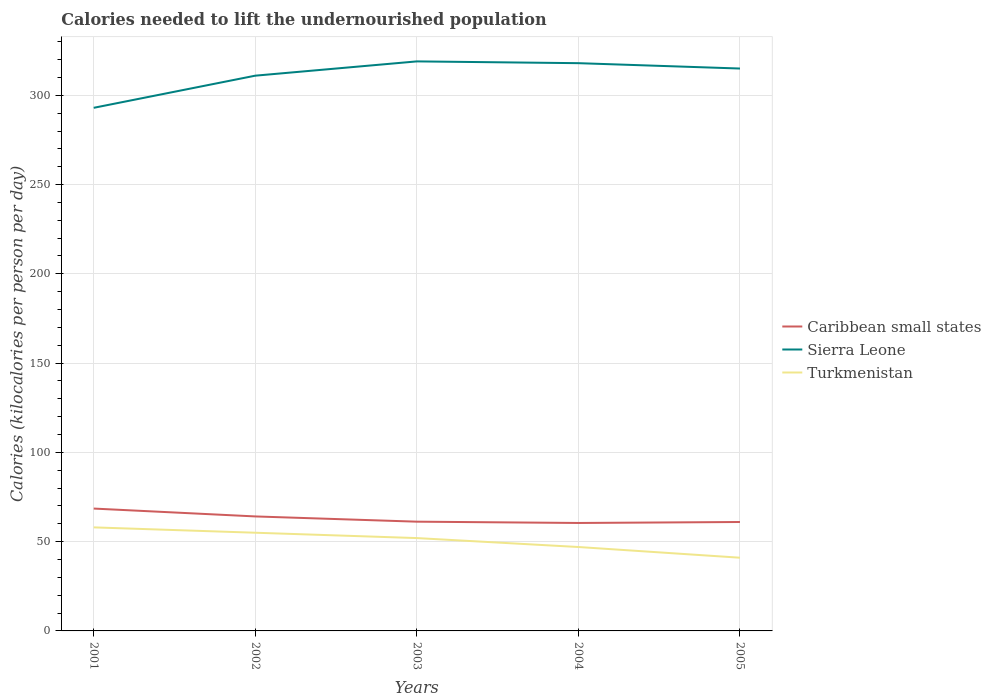Does the line corresponding to Caribbean small states intersect with the line corresponding to Sierra Leone?
Offer a terse response. No. Is the number of lines equal to the number of legend labels?
Give a very brief answer. Yes. Across all years, what is the maximum total calories needed to lift the undernourished population in Turkmenistan?
Ensure brevity in your answer.  41. In which year was the total calories needed to lift the undernourished population in Turkmenistan maximum?
Ensure brevity in your answer.  2005. What is the total total calories needed to lift the undernourished population in Turkmenistan in the graph?
Keep it short and to the point. 6. What is the difference between the highest and the second highest total calories needed to lift the undernourished population in Caribbean small states?
Your answer should be very brief. 8.07. What is the difference between the highest and the lowest total calories needed to lift the undernourished population in Turkmenistan?
Provide a succinct answer. 3. Is the total calories needed to lift the undernourished population in Caribbean small states strictly greater than the total calories needed to lift the undernourished population in Sierra Leone over the years?
Your response must be concise. Yes. How many lines are there?
Offer a terse response. 3. Does the graph contain any zero values?
Your answer should be very brief. No. Where does the legend appear in the graph?
Make the answer very short. Center right. How many legend labels are there?
Make the answer very short. 3. What is the title of the graph?
Provide a succinct answer. Calories needed to lift the undernourished population. Does "Channel Islands" appear as one of the legend labels in the graph?
Provide a succinct answer. No. What is the label or title of the Y-axis?
Make the answer very short. Calories (kilocalories per person per day). What is the Calories (kilocalories per person per day) in Caribbean small states in 2001?
Offer a terse response. 68.53. What is the Calories (kilocalories per person per day) in Sierra Leone in 2001?
Make the answer very short. 293. What is the Calories (kilocalories per person per day) in Turkmenistan in 2001?
Make the answer very short. 58. What is the Calories (kilocalories per person per day) in Caribbean small states in 2002?
Ensure brevity in your answer.  64.13. What is the Calories (kilocalories per person per day) of Sierra Leone in 2002?
Provide a short and direct response. 311. What is the Calories (kilocalories per person per day) in Caribbean small states in 2003?
Provide a succinct answer. 61.2. What is the Calories (kilocalories per person per day) of Sierra Leone in 2003?
Make the answer very short. 319. What is the Calories (kilocalories per person per day) of Caribbean small states in 2004?
Your answer should be very brief. 60.46. What is the Calories (kilocalories per person per day) of Sierra Leone in 2004?
Make the answer very short. 318. What is the Calories (kilocalories per person per day) in Caribbean small states in 2005?
Keep it short and to the point. 61.01. What is the Calories (kilocalories per person per day) of Sierra Leone in 2005?
Offer a terse response. 315. Across all years, what is the maximum Calories (kilocalories per person per day) of Caribbean small states?
Make the answer very short. 68.53. Across all years, what is the maximum Calories (kilocalories per person per day) in Sierra Leone?
Your answer should be compact. 319. Across all years, what is the maximum Calories (kilocalories per person per day) of Turkmenistan?
Provide a short and direct response. 58. Across all years, what is the minimum Calories (kilocalories per person per day) of Caribbean small states?
Keep it short and to the point. 60.46. Across all years, what is the minimum Calories (kilocalories per person per day) in Sierra Leone?
Provide a short and direct response. 293. Across all years, what is the minimum Calories (kilocalories per person per day) of Turkmenistan?
Your answer should be very brief. 41. What is the total Calories (kilocalories per person per day) of Caribbean small states in the graph?
Your answer should be very brief. 315.33. What is the total Calories (kilocalories per person per day) of Sierra Leone in the graph?
Provide a short and direct response. 1556. What is the total Calories (kilocalories per person per day) in Turkmenistan in the graph?
Your response must be concise. 253. What is the difference between the Calories (kilocalories per person per day) in Caribbean small states in 2001 and that in 2002?
Provide a succinct answer. 4.41. What is the difference between the Calories (kilocalories per person per day) in Sierra Leone in 2001 and that in 2002?
Offer a very short reply. -18. What is the difference between the Calories (kilocalories per person per day) of Turkmenistan in 2001 and that in 2002?
Give a very brief answer. 3. What is the difference between the Calories (kilocalories per person per day) in Caribbean small states in 2001 and that in 2003?
Keep it short and to the point. 7.34. What is the difference between the Calories (kilocalories per person per day) of Caribbean small states in 2001 and that in 2004?
Give a very brief answer. 8.07. What is the difference between the Calories (kilocalories per person per day) in Turkmenistan in 2001 and that in 2004?
Provide a succinct answer. 11. What is the difference between the Calories (kilocalories per person per day) in Caribbean small states in 2001 and that in 2005?
Make the answer very short. 7.53. What is the difference between the Calories (kilocalories per person per day) in Turkmenistan in 2001 and that in 2005?
Provide a short and direct response. 17. What is the difference between the Calories (kilocalories per person per day) of Caribbean small states in 2002 and that in 2003?
Your response must be concise. 2.93. What is the difference between the Calories (kilocalories per person per day) in Sierra Leone in 2002 and that in 2003?
Give a very brief answer. -8. What is the difference between the Calories (kilocalories per person per day) of Caribbean small states in 2002 and that in 2004?
Provide a short and direct response. 3.67. What is the difference between the Calories (kilocalories per person per day) of Sierra Leone in 2002 and that in 2004?
Your answer should be very brief. -7. What is the difference between the Calories (kilocalories per person per day) in Turkmenistan in 2002 and that in 2004?
Your answer should be compact. 8. What is the difference between the Calories (kilocalories per person per day) in Caribbean small states in 2002 and that in 2005?
Your response must be concise. 3.12. What is the difference between the Calories (kilocalories per person per day) of Turkmenistan in 2002 and that in 2005?
Ensure brevity in your answer.  14. What is the difference between the Calories (kilocalories per person per day) of Caribbean small states in 2003 and that in 2004?
Keep it short and to the point. 0.73. What is the difference between the Calories (kilocalories per person per day) in Caribbean small states in 2003 and that in 2005?
Make the answer very short. 0.19. What is the difference between the Calories (kilocalories per person per day) of Sierra Leone in 2003 and that in 2005?
Provide a short and direct response. 4. What is the difference between the Calories (kilocalories per person per day) of Caribbean small states in 2004 and that in 2005?
Offer a very short reply. -0.54. What is the difference between the Calories (kilocalories per person per day) of Turkmenistan in 2004 and that in 2005?
Provide a succinct answer. 6. What is the difference between the Calories (kilocalories per person per day) in Caribbean small states in 2001 and the Calories (kilocalories per person per day) in Sierra Leone in 2002?
Ensure brevity in your answer.  -242.47. What is the difference between the Calories (kilocalories per person per day) of Caribbean small states in 2001 and the Calories (kilocalories per person per day) of Turkmenistan in 2002?
Give a very brief answer. 13.53. What is the difference between the Calories (kilocalories per person per day) of Sierra Leone in 2001 and the Calories (kilocalories per person per day) of Turkmenistan in 2002?
Provide a succinct answer. 238. What is the difference between the Calories (kilocalories per person per day) of Caribbean small states in 2001 and the Calories (kilocalories per person per day) of Sierra Leone in 2003?
Ensure brevity in your answer.  -250.47. What is the difference between the Calories (kilocalories per person per day) in Caribbean small states in 2001 and the Calories (kilocalories per person per day) in Turkmenistan in 2003?
Offer a terse response. 16.53. What is the difference between the Calories (kilocalories per person per day) of Sierra Leone in 2001 and the Calories (kilocalories per person per day) of Turkmenistan in 2003?
Provide a succinct answer. 241. What is the difference between the Calories (kilocalories per person per day) of Caribbean small states in 2001 and the Calories (kilocalories per person per day) of Sierra Leone in 2004?
Offer a terse response. -249.47. What is the difference between the Calories (kilocalories per person per day) in Caribbean small states in 2001 and the Calories (kilocalories per person per day) in Turkmenistan in 2004?
Provide a succinct answer. 21.53. What is the difference between the Calories (kilocalories per person per day) in Sierra Leone in 2001 and the Calories (kilocalories per person per day) in Turkmenistan in 2004?
Give a very brief answer. 246. What is the difference between the Calories (kilocalories per person per day) of Caribbean small states in 2001 and the Calories (kilocalories per person per day) of Sierra Leone in 2005?
Provide a short and direct response. -246.47. What is the difference between the Calories (kilocalories per person per day) of Caribbean small states in 2001 and the Calories (kilocalories per person per day) of Turkmenistan in 2005?
Offer a very short reply. 27.53. What is the difference between the Calories (kilocalories per person per day) of Sierra Leone in 2001 and the Calories (kilocalories per person per day) of Turkmenistan in 2005?
Offer a terse response. 252. What is the difference between the Calories (kilocalories per person per day) of Caribbean small states in 2002 and the Calories (kilocalories per person per day) of Sierra Leone in 2003?
Provide a succinct answer. -254.87. What is the difference between the Calories (kilocalories per person per day) in Caribbean small states in 2002 and the Calories (kilocalories per person per day) in Turkmenistan in 2003?
Provide a short and direct response. 12.13. What is the difference between the Calories (kilocalories per person per day) of Sierra Leone in 2002 and the Calories (kilocalories per person per day) of Turkmenistan in 2003?
Keep it short and to the point. 259. What is the difference between the Calories (kilocalories per person per day) of Caribbean small states in 2002 and the Calories (kilocalories per person per day) of Sierra Leone in 2004?
Keep it short and to the point. -253.87. What is the difference between the Calories (kilocalories per person per day) of Caribbean small states in 2002 and the Calories (kilocalories per person per day) of Turkmenistan in 2004?
Offer a very short reply. 17.13. What is the difference between the Calories (kilocalories per person per day) of Sierra Leone in 2002 and the Calories (kilocalories per person per day) of Turkmenistan in 2004?
Give a very brief answer. 264. What is the difference between the Calories (kilocalories per person per day) of Caribbean small states in 2002 and the Calories (kilocalories per person per day) of Sierra Leone in 2005?
Keep it short and to the point. -250.87. What is the difference between the Calories (kilocalories per person per day) of Caribbean small states in 2002 and the Calories (kilocalories per person per day) of Turkmenistan in 2005?
Your response must be concise. 23.13. What is the difference between the Calories (kilocalories per person per day) in Sierra Leone in 2002 and the Calories (kilocalories per person per day) in Turkmenistan in 2005?
Offer a very short reply. 270. What is the difference between the Calories (kilocalories per person per day) in Caribbean small states in 2003 and the Calories (kilocalories per person per day) in Sierra Leone in 2004?
Your response must be concise. -256.8. What is the difference between the Calories (kilocalories per person per day) in Caribbean small states in 2003 and the Calories (kilocalories per person per day) in Turkmenistan in 2004?
Provide a succinct answer. 14.2. What is the difference between the Calories (kilocalories per person per day) of Sierra Leone in 2003 and the Calories (kilocalories per person per day) of Turkmenistan in 2004?
Offer a very short reply. 272. What is the difference between the Calories (kilocalories per person per day) of Caribbean small states in 2003 and the Calories (kilocalories per person per day) of Sierra Leone in 2005?
Your response must be concise. -253.8. What is the difference between the Calories (kilocalories per person per day) of Caribbean small states in 2003 and the Calories (kilocalories per person per day) of Turkmenistan in 2005?
Keep it short and to the point. 20.2. What is the difference between the Calories (kilocalories per person per day) of Sierra Leone in 2003 and the Calories (kilocalories per person per day) of Turkmenistan in 2005?
Your answer should be very brief. 278. What is the difference between the Calories (kilocalories per person per day) in Caribbean small states in 2004 and the Calories (kilocalories per person per day) in Sierra Leone in 2005?
Give a very brief answer. -254.54. What is the difference between the Calories (kilocalories per person per day) of Caribbean small states in 2004 and the Calories (kilocalories per person per day) of Turkmenistan in 2005?
Give a very brief answer. 19.46. What is the difference between the Calories (kilocalories per person per day) in Sierra Leone in 2004 and the Calories (kilocalories per person per day) in Turkmenistan in 2005?
Your answer should be very brief. 277. What is the average Calories (kilocalories per person per day) of Caribbean small states per year?
Ensure brevity in your answer.  63.07. What is the average Calories (kilocalories per person per day) in Sierra Leone per year?
Offer a very short reply. 311.2. What is the average Calories (kilocalories per person per day) in Turkmenistan per year?
Your answer should be very brief. 50.6. In the year 2001, what is the difference between the Calories (kilocalories per person per day) in Caribbean small states and Calories (kilocalories per person per day) in Sierra Leone?
Offer a terse response. -224.47. In the year 2001, what is the difference between the Calories (kilocalories per person per day) of Caribbean small states and Calories (kilocalories per person per day) of Turkmenistan?
Keep it short and to the point. 10.53. In the year 2001, what is the difference between the Calories (kilocalories per person per day) of Sierra Leone and Calories (kilocalories per person per day) of Turkmenistan?
Your response must be concise. 235. In the year 2002, what is the difference between the Calories (kilocalories per person per day) in Caribbean small states and Calories (kilocalories per person per day) in Sierra Leone?
Keep it short and to the point. -246.87. In the year 2002, what is the difference between the Calories (kilocalories per person per day) of Caribbean small states and Calories (kilocalories per person per day) of Turkmenistan?
Make the answer very short. 9.13. In the year 2002, what is the difference between the Calories (kilocalories per person per day) in Sierra Leone and Calories (kilocalories per person per day) in Turkmenistan?
Ensure brevity in your answer.  256. In the year 2003, what is the difference between the Calories (kilocalories per person per day) of Caribbean small states and Calories (kilocalories per person per day) of Sierra Leone?
Give a very brief answer. -257.8. In the year 2003, what is the difference between the Calories (kilocalories per person per day) in Caribbean small states and Calories (kilocalories per person per day) in Turkmenistan?
Keep it short and to the point. 9.2. In the year 2003, what is the difference between the Calories (kilocalories per person per day) of Sierra Leone and Calories (kilocalories per person per day) of Turkmenistan?
Keep it short and to the point. 267. In the year 2004, what is the difference between the Calories (kilocalories per person per day) of Caribbean small states and Calories (kilocalories per person per day) of Sierra Leone?
Offer a terse response. -257.54. In the year 2004, what is the difference between the Calories (kilocalories per person per day) of Caribbean small states and Calories (kilocalories per person per day) of Turkmenistan?
Keep it short and to the point. 13.46. In the year 2004, what is the difference between the Calories (kilocalories per person per day) of Sierra Leone and Calories (kilocalories per person per day) of Turkmenistan?
Your response must be concise. 271. In the year 2005, what is the difference between the Calories (kilocalories per person per day) in Caribbean small states and Calories (kilocalories per person per day) in Sierra Leone?
Keep it short and to the point. -253.99. In the year 2005, what is the difference between the Calories (kilocalories per person per day) of Caribbean small states and Calories (kilocalories per person per day) of Turkmenistan?
Offer a very short reply. 20.01. In the year 2005, what is the difference between the Calories (kilocalories per person per day) in Sierra Leone and Calories (kilocalories per person per day) in Turkmenistan?
Your answer should be compact. 274. What is the ratio of the Calories (kilocalories per person per day) of Caribbean small states in 2001 to that in 2002?
Keep it short and to the point. 1.07. What is the ratio of the Calories (kilocalories per person per day) in Sierra Leone in 2001 to that in 2002?
Provide a short and direct response. 0.94. What is the ratio of the Calories (kilocalories per person per day) in Turkmenistan in 2001 to that in 2002?
Give a very brief answer. 1.05. What is the ratio of the Calories (kilocalories per person per day) of Caribbean small states in 2001 to that in 2003?
Your answer should be very brief. 1.12. What is the ratio of the Calories (kilocalories per person per day) in Sierra Leone in 2001 to that in 2003?
Offer a terse response. 0.92. What is the ratio of the Calories (kilocalories per person per day) in Turkmenistan in 2001 to that in 2003?
Provide a succinct answer. 1.12. What is the ratio of the Calories (kilocalories per person per day) in Caribbean small states in 2001 to that in 2004?
Your answer should be very brief. 1.13. What is the ratio of the Calories (kilocalories per person per day) of Sierra Leone in 2001 to that in 2004?
Provide a succinct answer. 0.92. What is the ratio of the Calories (kilocalories per person per day) of Turkmenistan in 2001 to that in 2004?
Keep it short and to the point. 1.23. What is the ratio of the Calories (kilocalories per person per day) in Caribbean small states in 2001 to that in 2005?
Make the answer very short. 1.12. What is the ratio of the Calories (kilocalories per person per day) of Sierra Leone in 2001 to that in 2005?
Your response must be concise. 0.93. What is the ratio of the Calories (kilocalories per person per day) in Turkmenistan in 2001 to that in 2005?
Provide a succinct answer. 1.41. What is the ratio of the Calories (kilocalories per person per day) of Caribbean small states in 2002 to that in 2003?
Ensure brevity in your answer.  1.05. What is the ratio of the Calories (kilocalories per person per day) in Sierra Leone in 2002 to that in 2003?
Offer a very short reply. 0.97. What is the ratio of the Calories (kilocalories per person per day) in Turkmenistan in 2002 to that in 2003?
Keep it short and to the point. 1.06. What is the ratio of the Calories (kilocalories per person per day) in Caribbean small states in 2002 to that in 2004?
Offer a terse response. 1.06. What is the ratio of the Calories (kilocalories per person per day) of Sierra Leone in 2002 to that in 2004?
Make the answer very short. 0.98. What is the ratio of the Calories (kilocalories per person per day) of Turkmenistan in 2002 to that in 2004?
Your answer should be compact. 1.17. What is the ratio of the Calories (kilocalories per person per day) in Caribbean small states in 2002 to that in 2005?
Your answer should be compact. 1.05. What is the ratio of the Calories (kilocalories per person per day) in Sierra Leone in 2002 to that in 2005?
Your answer should be very brief. 0.99. What is the ratio of the Calories (kilocalories per person per day) in Turkmenistan in 2002 to that in 2005?
Your answer should be very brief. 1.34. What is the ratio of the Calories (kilocalories per person per day) in Caribbean small states in 2003 to that in 2004?
Ensure brevity in your answer.  1.01. What is the ratio of the Calories (kilocalories per person per day) in Sierra Leone in 2003 to that in 2004?
Provide a succinct answer. 1. What is the ratio of the Calories (kilocalories per person per day) of Turkmenistan in 2003 to that in 2004?
Your answer should be compact. 1.11. What is the ratio of the Calories (kilocalories per person per day) in Caribbean small states in 2003 to that in 2005?
Give a very brief answer. 1. What is the ratio of the Calories (kilocalories per person per day) in Sierra Leone in 2003 to that in 2005?
Your answer should be compact. 1.01. What is the ratio of the Calories (kilocalories per person per day) of Turkmenistan in 2003 to that in 2005?
Offer a very short reply. 1.27. What is the ratio of the Calories (kilocalories per person per day) in Caribbean small states in 2004 to that in 2005?
Give a very brief answer. 0.99. What is the ratio of the Calories (kilocalories per person per day) of Sierra Leone in 2004 to that in 2005?
Provide a succinct answer. 1.01. What is the ratio of the Calories (kilocalories per person per day) in Turkmenistan in 2004 to that in 2005?
Give a very brief answer. 1.15. What is the difference between the highest and the second highest Calories (kilocalories per person per day) of Caribbean small states?
Make the answer very short. 4.41. What is the difference between the highest and the second highest Calories (kilocalories per person per day) of Turkmenistan?
Make the answer very short. 3. What is the difference between the highest and the lowest Calories (kilocalories per person per day) in Caribbean small states?
Offer a terse response. 8.07. What is the difference between the highest and the lowest Calories (kilocalories per person per day) in Turkmenistan?
Your answer should be compact. 17. 